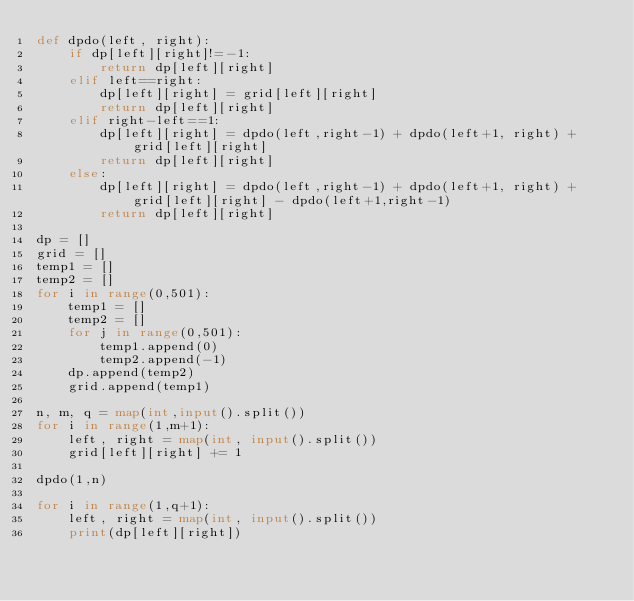<code> <loc_0><loc_0><loc_500><loc_500><_Python_>def dpdo(left, right):
    if dp[left][right]!=-1:
        return dp[left][right]
    elif left==right:
        dp[left][right] = grid[left][right]
        return dp[left][right]
    elif right-left==1:
        dp[left][right] = dpdo(left,right-1) + dpdo(left+1, right) + grid[left][right]
        return dp[left][right]
    else:
        dp[left][right] = dpdo(left,right-1) + dpdo(left+1, right) + grid[left][right] - dpdo(left+1,right-1)
        return dp[left][right]

dp = []
grid = []
temp1 = []
temp2 = []
for i in range(0,501):
    temp1 = []
    temp2 = []
    for j in range(0,501):
        temp1.append(0)
        temp2.append(-1)
    dp.append(temp2)
    grid.append(temp1)
    
n, m, q = map(int,input().split())
for i in range(1,m+1):
    left, right = map(int, input().split())
    grid[left][right] += 1
    
dpdo(1,n)

for i in range(1,q+1):
    left, right = map(int, input().split())
    print(dp[left][right])</code> 